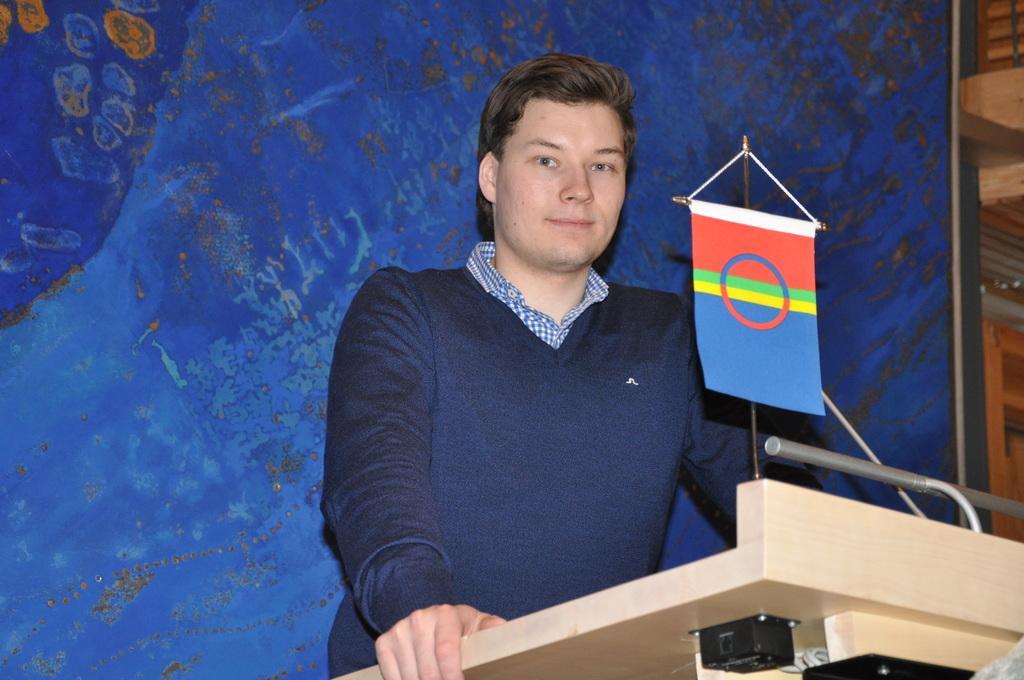Describe this image in one or two sentences. This picture might be taken inside a conference hall. In this image, we can see a man wearing a blue color shirt is standing in front of the podium, on that podium, we can see a flag. in the background, we can see blue color. On the right side, we can see a door which is closed. 